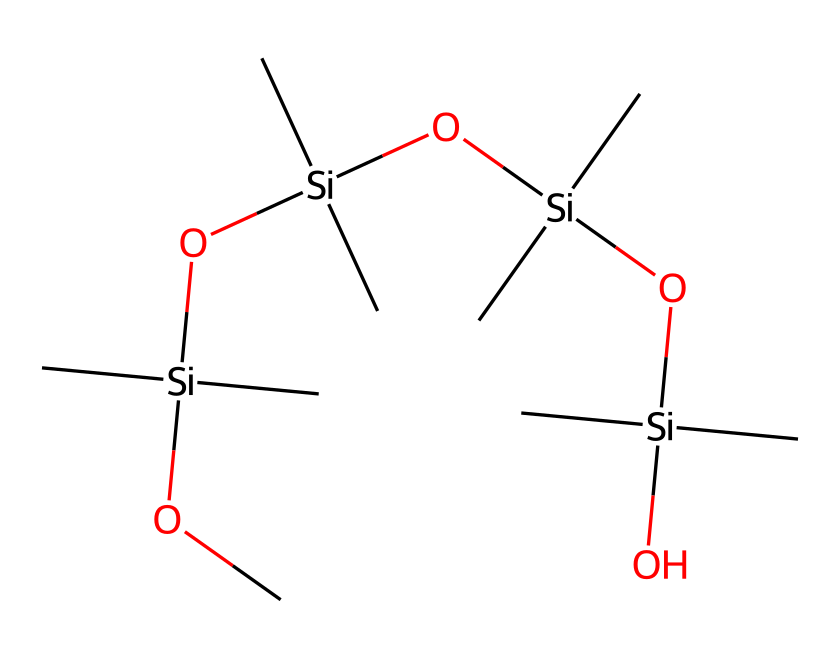What is the central atom in this chemical structure? The SMILES representation shows 'Si' prominently, indicating that silicon is the central atom in the structure.
Answer: silicon How many silicon atoms are present in the structure? The SMILES shows four '[Si]' notations, which indicates there are four silicon atoms in the compound.
Answer: four What functional group is featured in the polymer structure? The presence of 'O' adjacent to 'Si' indicates the presence of silanol (-Si-OH) groups, which are functional groups in silicone polymers.
Answer: silanol What is the overall type of polymer represented? The repetition of silicon and oxygen atoms, along with organic side chains, indicates that this is a silicone or organosilicon polymer.
Answer: organosilicon What is the main application of the polymer depicted in the structure? The presence of moisture-wicking properties suggests that this polymer is designed for use in athletic apparel to manage moisture.
Answer: athletic apparel How does the structure contribute to moisture-wicking properties? The silicon-oxygen bonds create a hydrophobic surface which helps repel water, assisting in moisture-wicking applications.
Answer: hydrophobic What type of bonding primarily occurs in this organosilicon compound? The structure primarily contains covalent bonding between silicon and oxygen atoms, along with carbon substituents.
Answer: covalent 